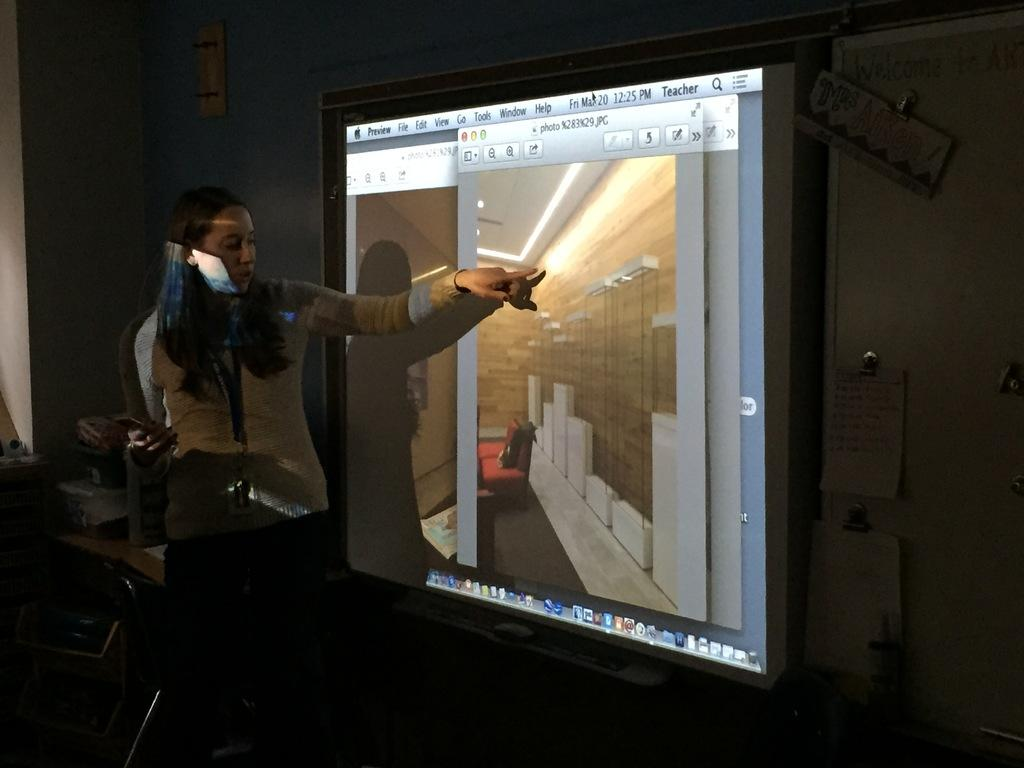What is the main subject of the image? There is a person standing in the image. What is the person wearing? The person is wearing a cream-colored jacket. What is in front of the person? There is a projector screen in front of the person. What can be observed about the background of the image? The background of the image is dark. What type of quiver can be seen on the person's back in the image? There is no quiver visible on the person's back in the image. How does the person slip on the floor in the image? The person is not slipping on the floor in the image; they are standing. 